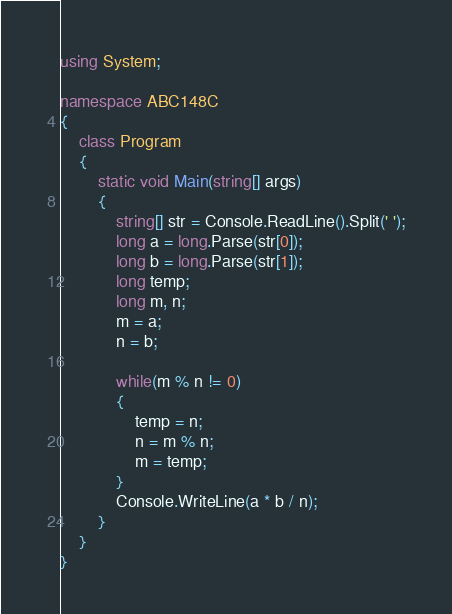<code> <loc_0><loc_0><loc_500><loc_500><_C#_>using System;

namespace ABC148C
{
	class Program
	{
		static void Main(string[] args)
		{
			string[] str = Console.ReadLine().Split(' ');
			long a = long.Parse(str[0]);
			long b = long.Parse(str[1]);
			long temp;
			long m, n;
			m = a;
			n = b;

			while(m % n != 0)
			{
				temp = n;
				n = m % n;
				m = temp;
			}
			Console.WriteLine(a * b / n);
		}
	}
}
</code> 